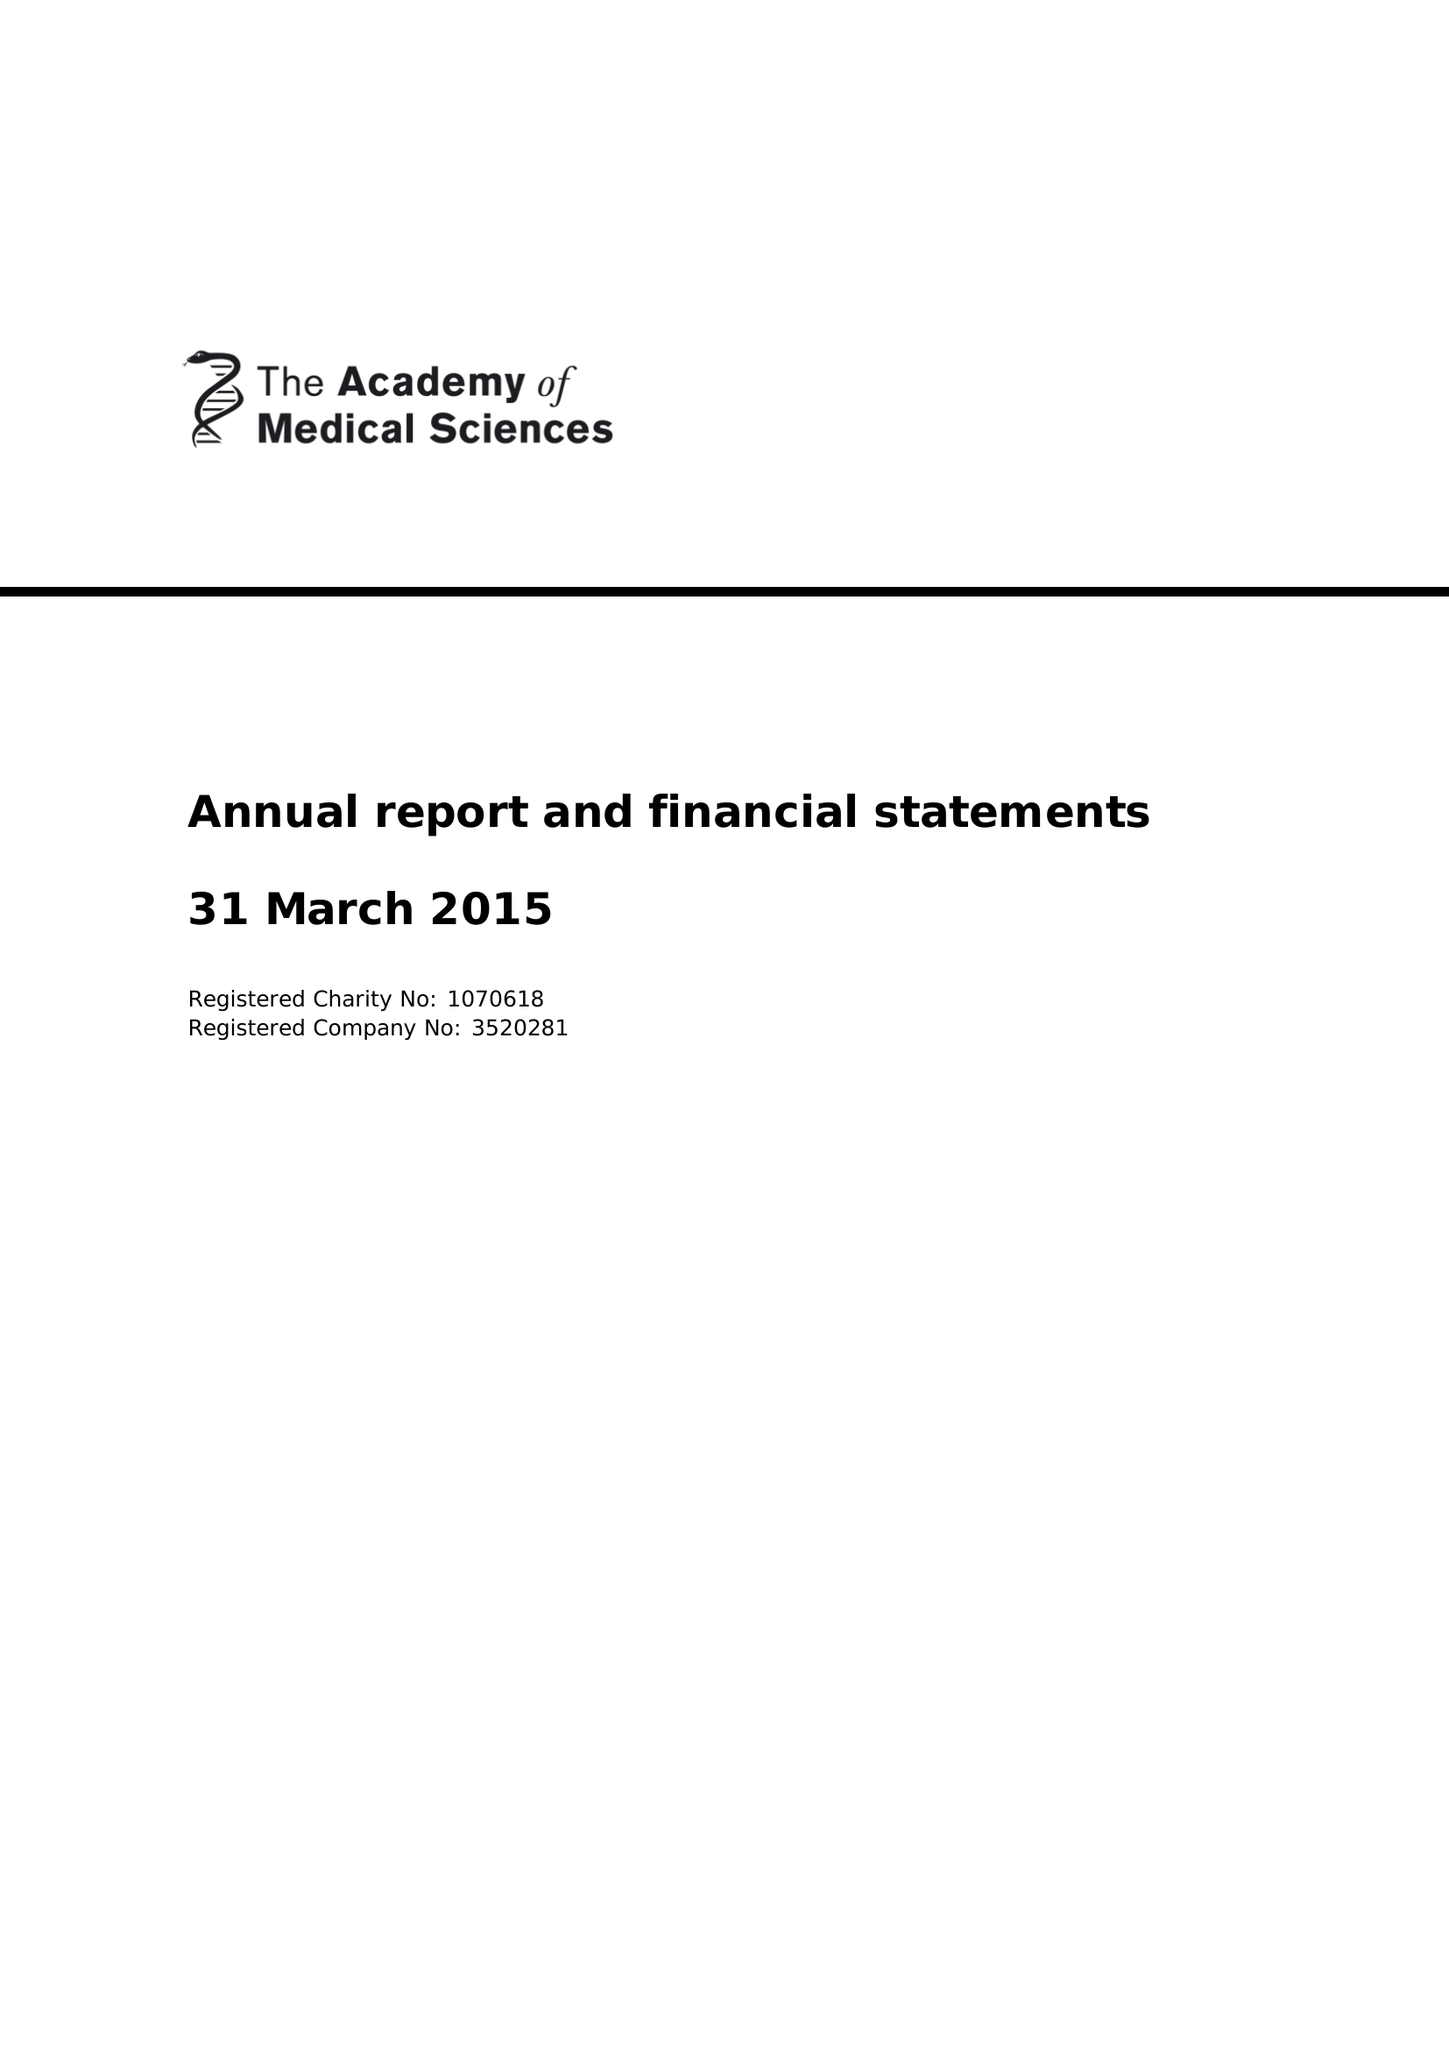What is the value for the address__post_town?
Answer the question using a single word or phrase. LONDON 